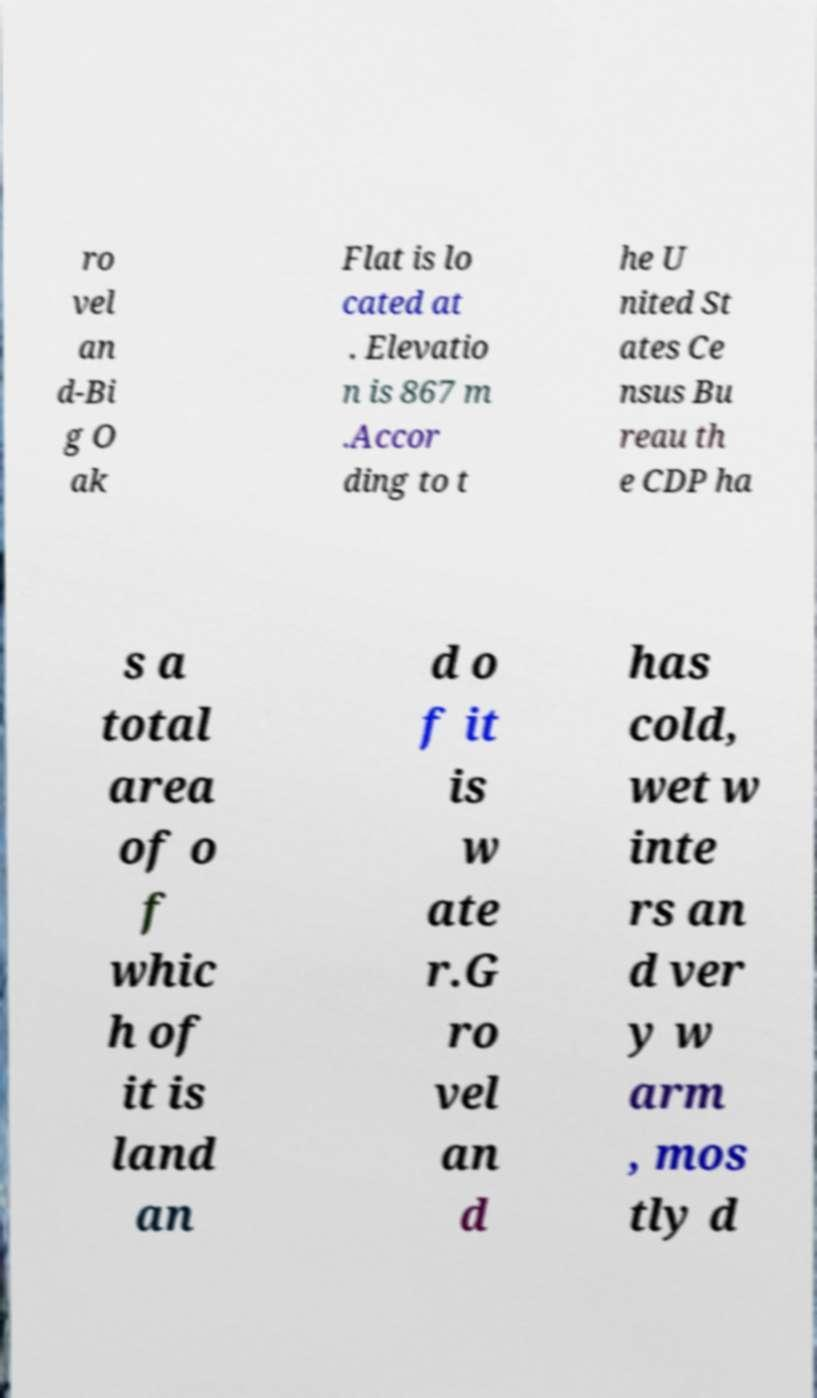Could you assist in decoding the text presented in this image and type it out clearly? ro vel an d-Bi g O ak Flat is lo cated at . Elevatio n is 867 m .Accor ding to t he U nited St ates Ce nsus Bu reau th e CDP ha s a total area of o f whic h of it is land an d o f it is w ate r.G ro vel an d has cold, wet w inte rs an d ver y w arm , mos tly d 